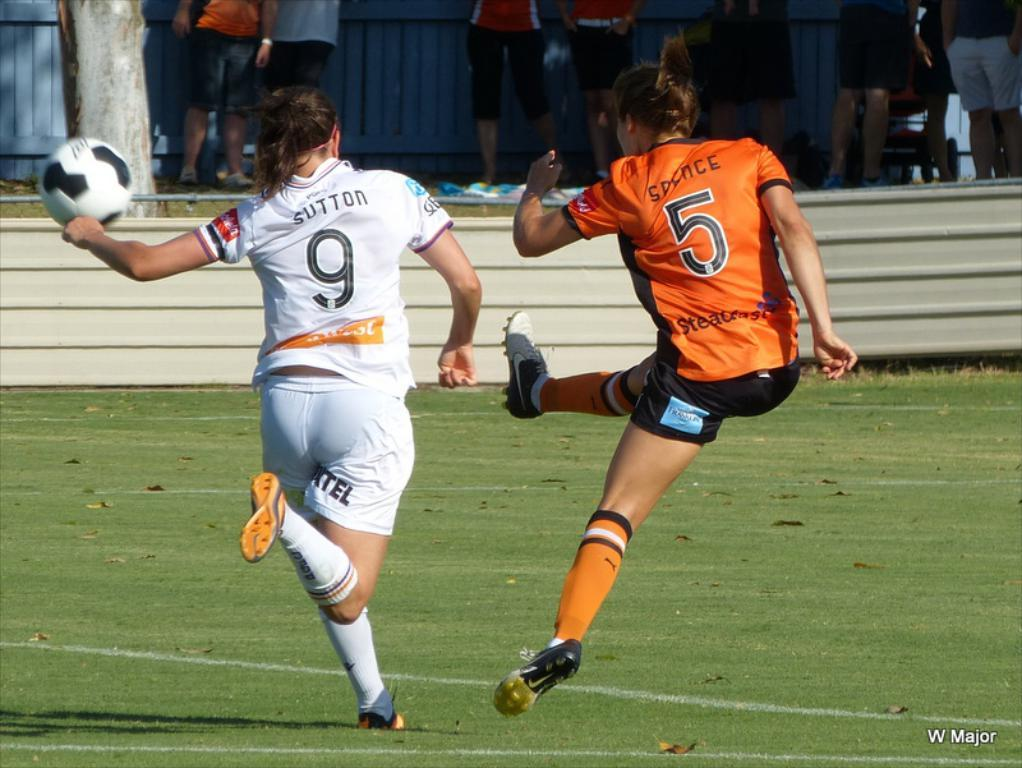<image>
Write a terse but informative summary of the picture. Player number 5 kicks a soccer ball as player 9 runs after her. 